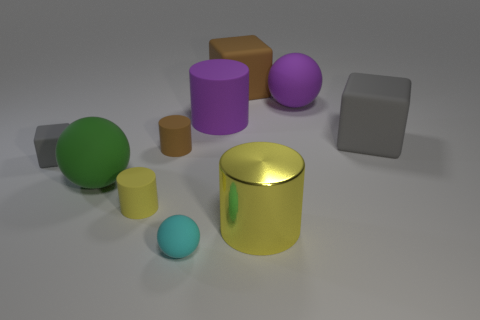Is there any other thing that is the same material as the big yellow thing?
Your answer should be very brief. No. What color is the small object that is the same shape as the big green thing?
Offer a terse response. Cyan. Are there more cubes than small yellow matte objects?
Keep it short and to the point. Yes. How many other objects are there of the same material as the big gray thing?
Offer a terse response. 8. The big green matte thing in front of the gray rubber block that is on the left side of the large ball to the left of the tiny sphere is what shape?
Give a very brief answer. Sphere. Are there fewer purple rubber cylinders that are behind the brown matte cube than matte spheres that are behind the large yellow thing?
Ensure brevity in your answer.  Yes. Is there a small matte cylinder that has the same color as the big shiny cylinder?
Keep it short and to the point. Yes. Does the big green sphere have the same material as the large cylinder that is to the right of the large brown block?
Offer a very short reply. No. Is there a yellow rubber object that is in front of the gray cube that is right of the tiny block?
Keep it short and to the point. Yes. There is a tiny matte thing that is behind the yellow matte object and left of the small brown object; what is its color?
Your response must be concise. Gray. 